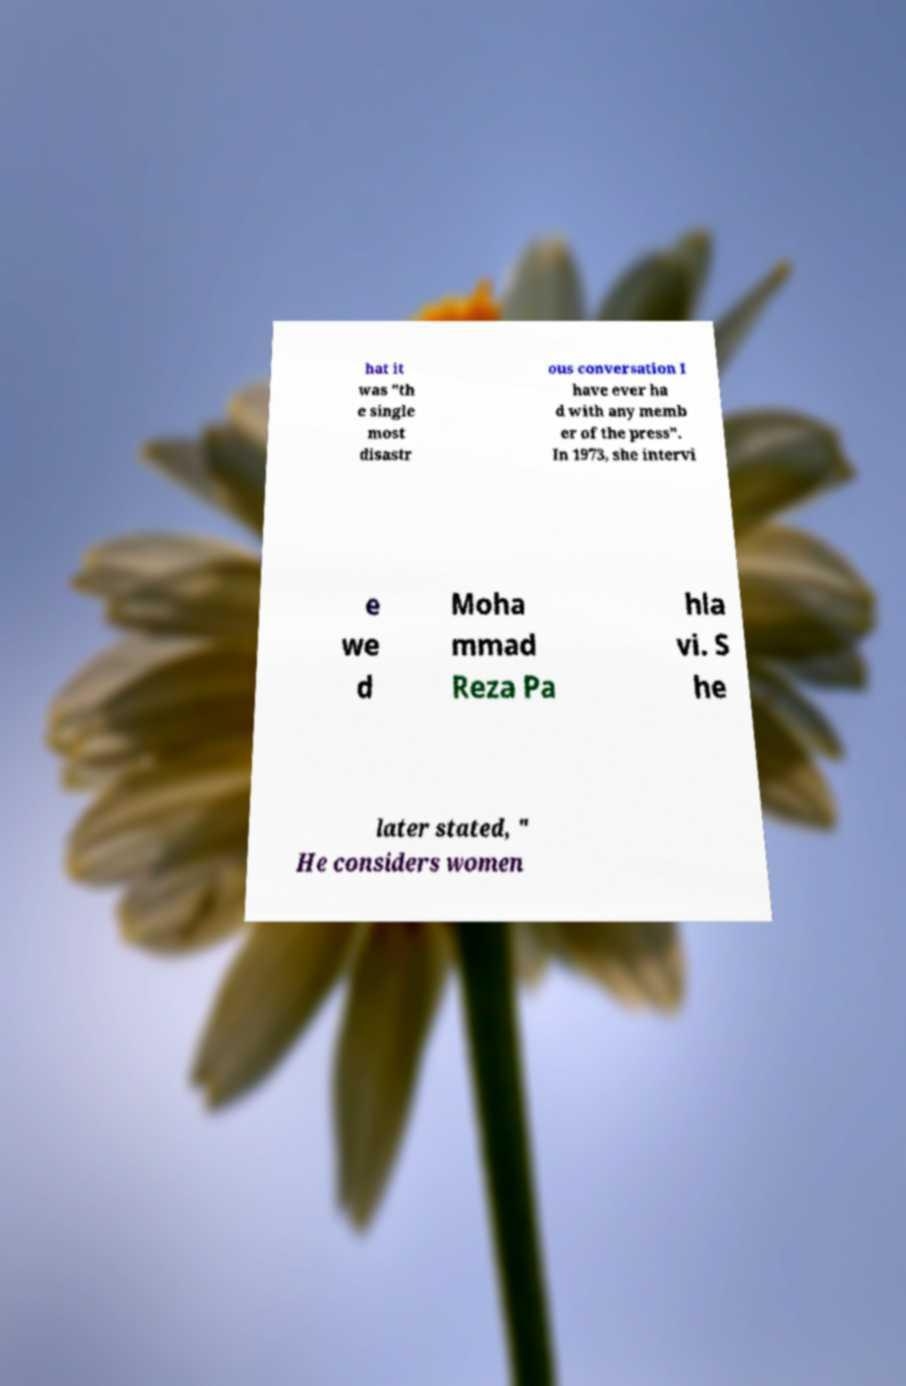There's text embedded in this image that I need extracted. Can you transcribe it verbatim? hat it was "th e single most disastr ous conversation I have ever ha d with any memb er of the press". In 1973, she intervi e we d Moha mmad Reza Pa hla vi. S he later stated, " He considers women 